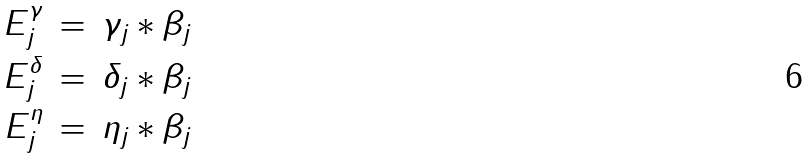Convert formula to latex. <formula><loc_0><loc_0><loc_500><loc_500>E _ { j } ^ { \gamma } & \, = \, \gamma _ { j } \ast \beta _ { j } \\ E _ { j } ^ { \delta } & \, = \, \delta _ { j } \ast \beta _ { j } \\ E _ { j } ^ { \eta } & \, = \, \eta _ { j } \ast \beta _ { j }</formula> 